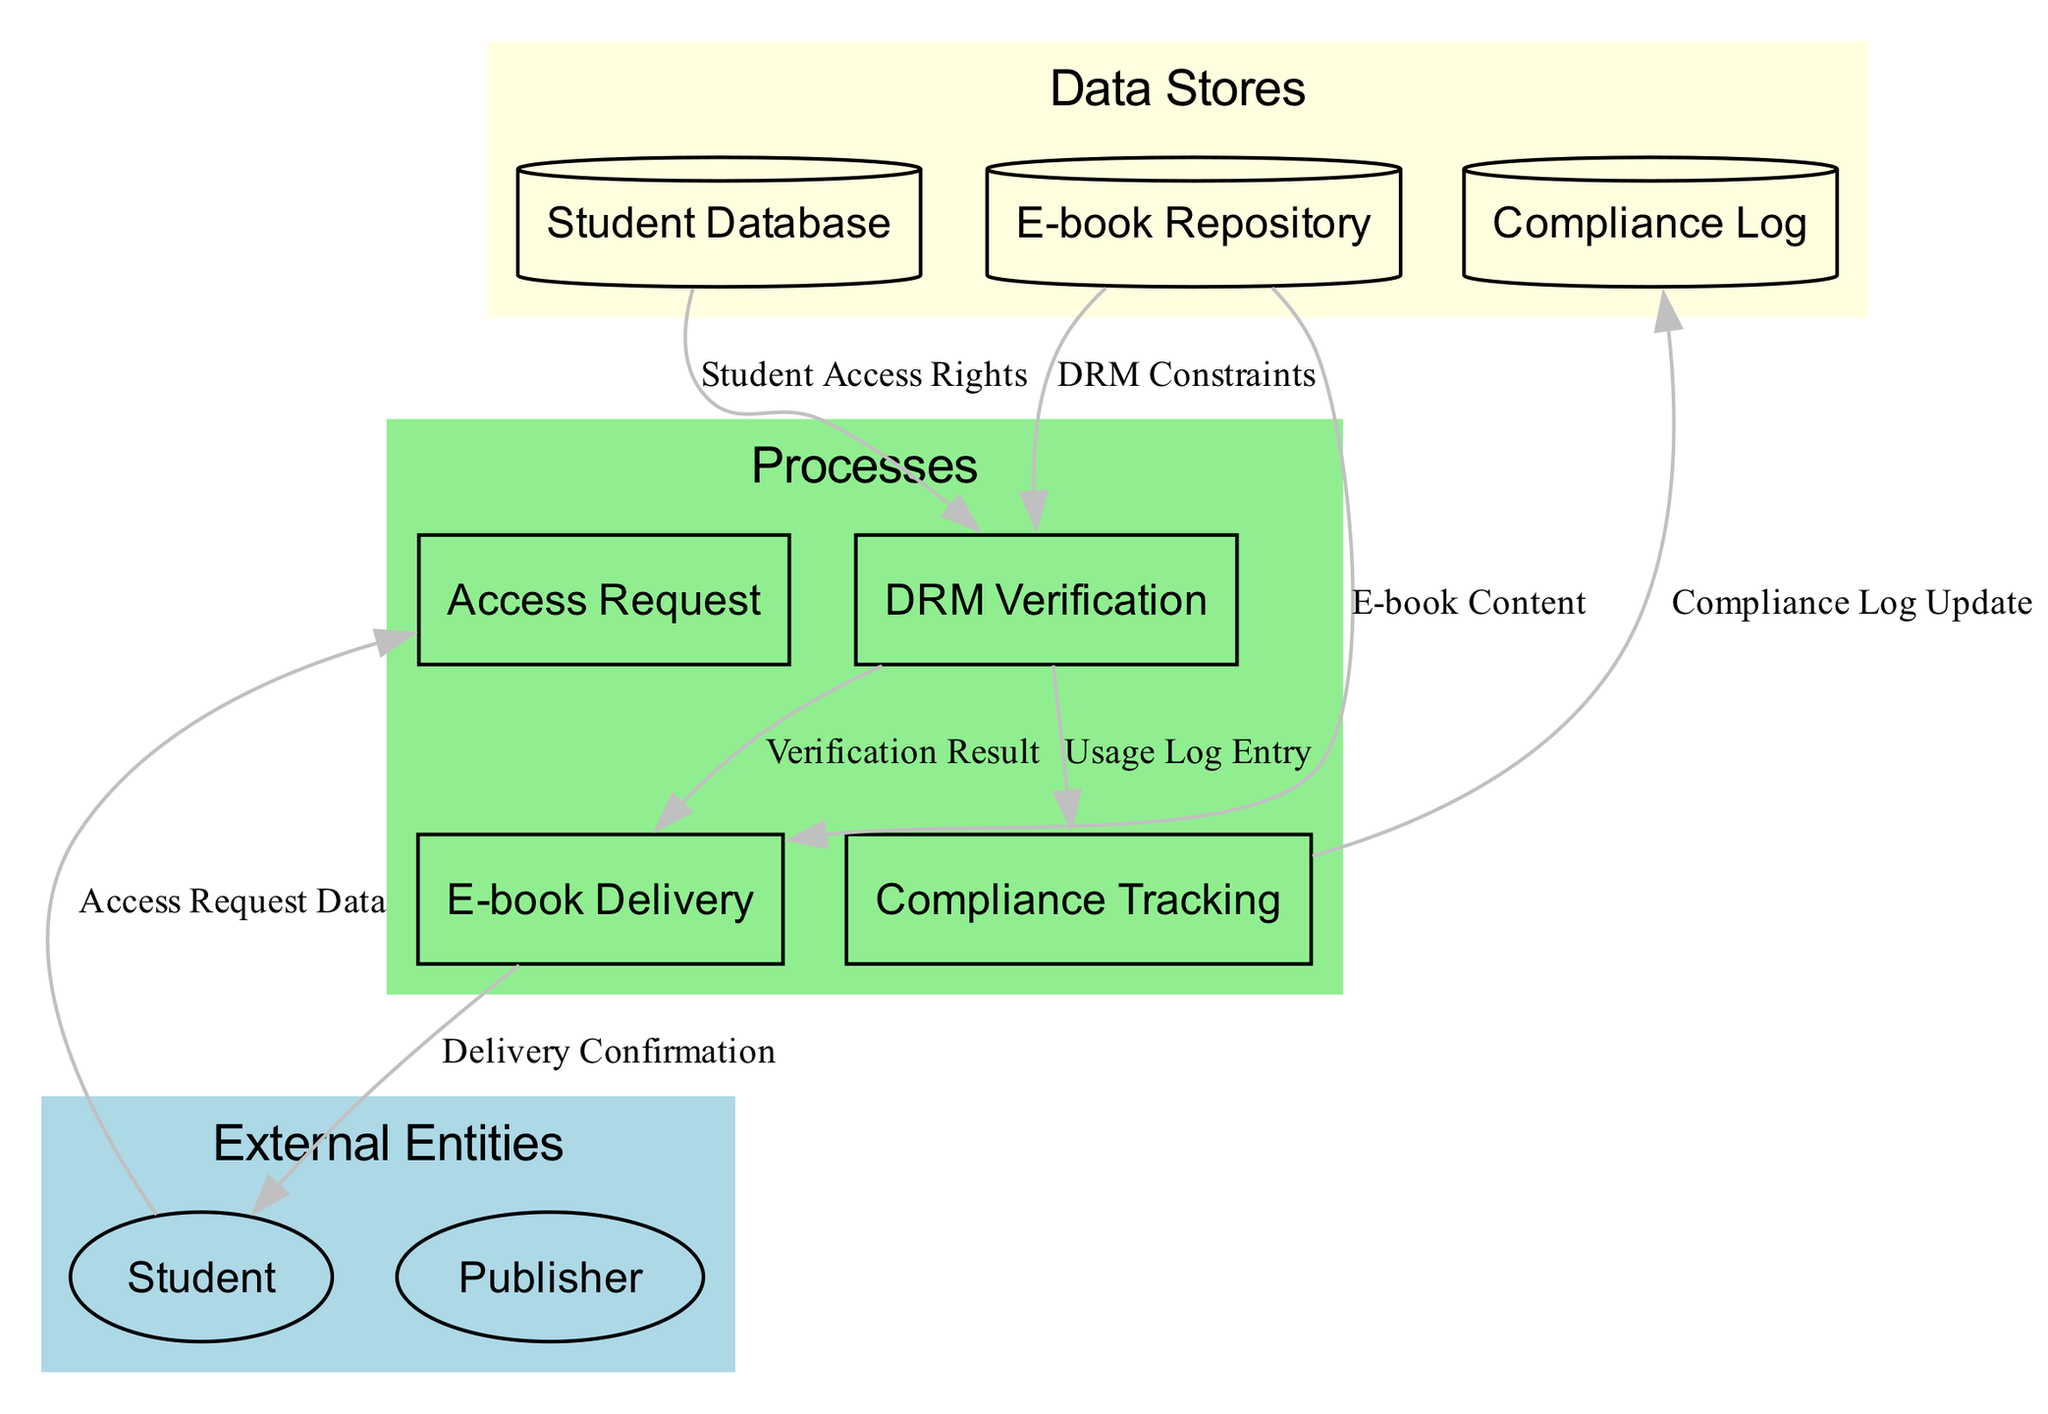What are the external entities represented in the diagram? The diagram includes two external entities: "Student" and "Publisher". They are depicted as ellipses in the External Entities section of the diagram.
Answer: Student, Publisher How many processes are shown in the diagram? The diagram presents four processes: "Access Request", "DRM Verification", "Compliance Tracking", and "E-book Delivery". These processes are represented as rectangles in the Processes section.
Answer: Four Which process receives the "Access Request Data"? The "Access Request" process is designated to receive the "Access Request Data" from the "Student". This relationship is indicated by the directed edge from "Student" to "Access Request".
Answer: Access Request What does the "Compliance Tracking" process output? The "Compliance Tracking" process outputs the "Compliance Log Update", which is sent to the "Compliance Log". This is shown in the data flow leading from "Compliance Tracking" to "Compliance Log".
Answer: Compliance Log Update Explain the flow of information from the student to the e-book delivery. The flow begins with the "Student" who initiates an "Access Request" containing the access details. This request is processed by the "Access Request" process, which checks access rights via "DRM Verification". If the verification is successful, an "E-book Delivery" occurs, delivering the e-book content back to the student, culminating in a "Delivery Confirmation".
Answer: Student → Access Request → DRM Verification → E-book Delivery What type of data is stored in the "Compliance Log"? The "Compliance Log" stores "Updated log entry for access and usage data." This data is specifically logged by the "Compliance Tracking" process, as indicated by the arrow pointing to "Compliance Log".
Answer: Updated log entry for access and usage data Which data store contains information about student permissions? The "Student Database" contains information about students, including their access rights for e-books. This is implied by the flow leading from "Student Database" to "DRM Verification".
Answer: Student Database How many data flows are represented in the diagram? There are seven data flows represented in the diagram, each connecting various nodes. This can be counted from the directed edges connecting the different processes and data stores.
Answer: Seven What does the "Verification Result" signify in the context of this diagram? The "Verification Result" indicates the outcome of the "DRM Verification" process. This result determines whether the access request will be approved or denied and is directed towards the "E-book Delivery" process.
Answer: Outcome of DRM verification 